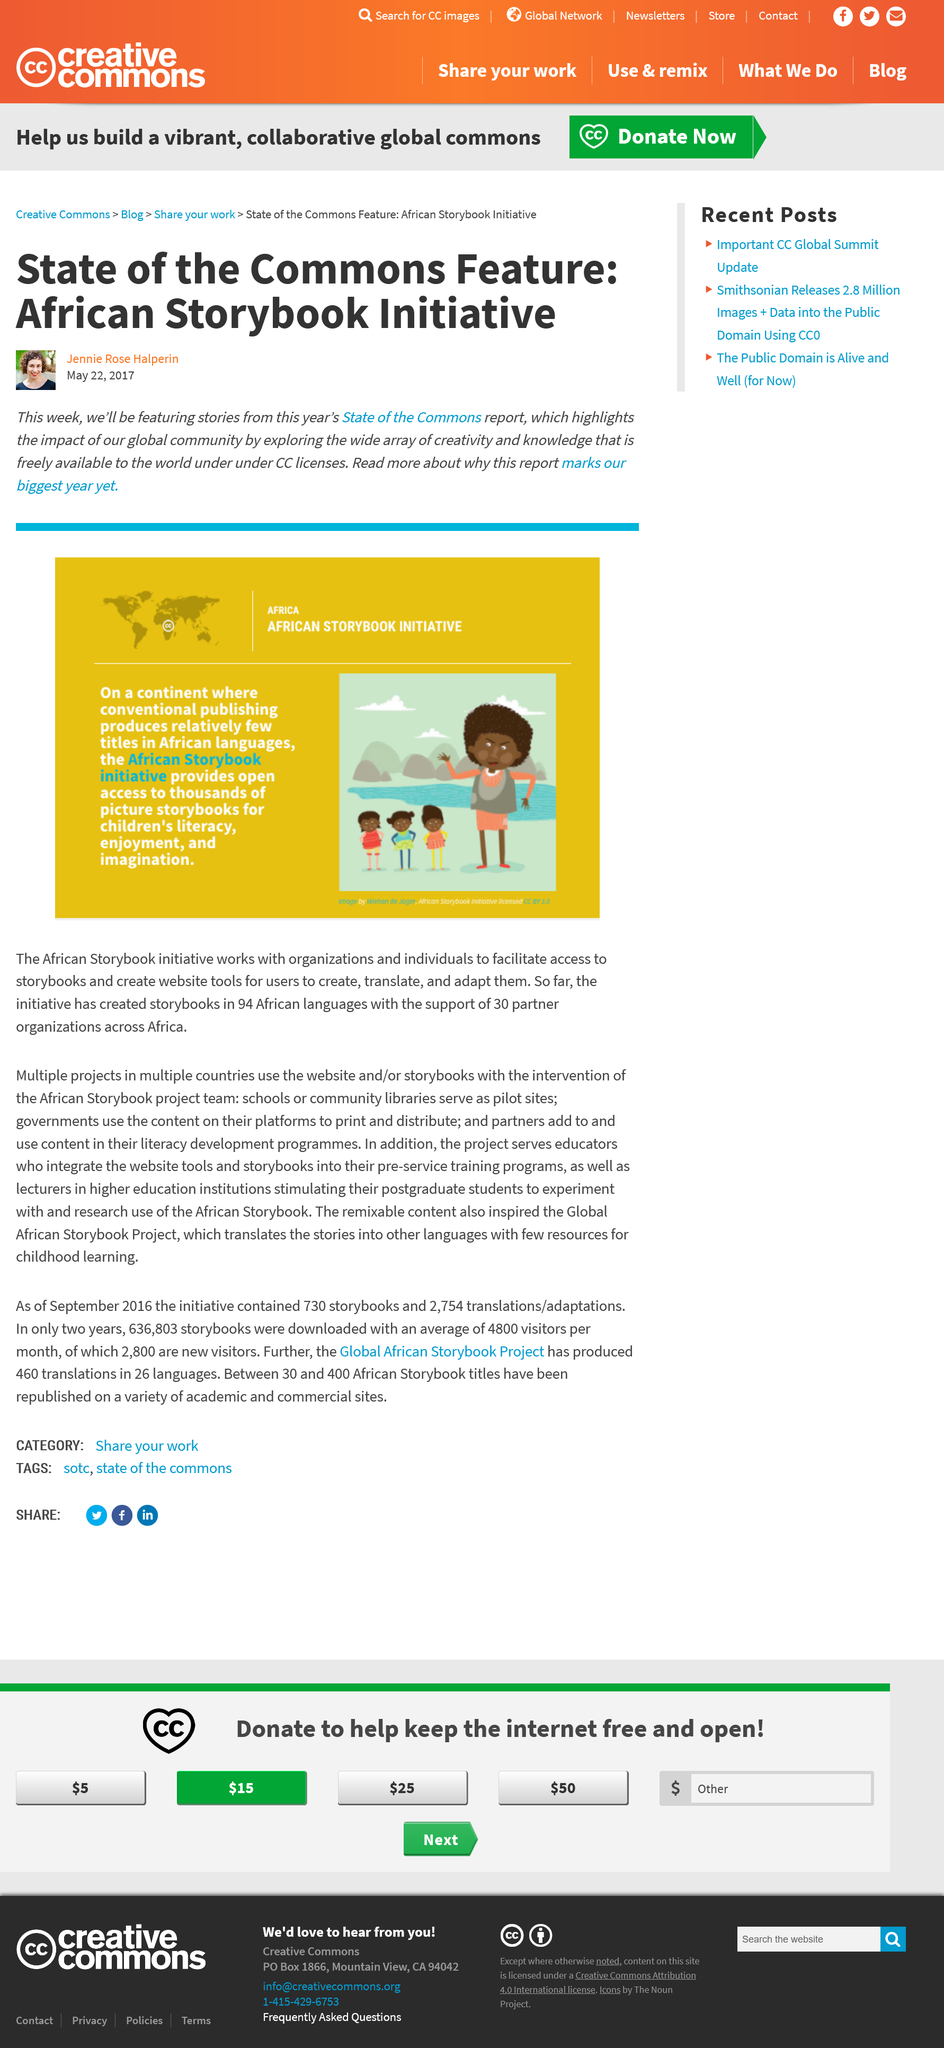Indicate a few pertinent items in this graphic. The Storybook Initiative provides children with open access to a vast collection of picture storybooks for the purpose of promoting their literacy, facilitating enjoyment, and stimulating their imagination. The stories will be featured from the State Of Commons Report this week. The story book initiative is currently being implemented on the continent of Africa. 